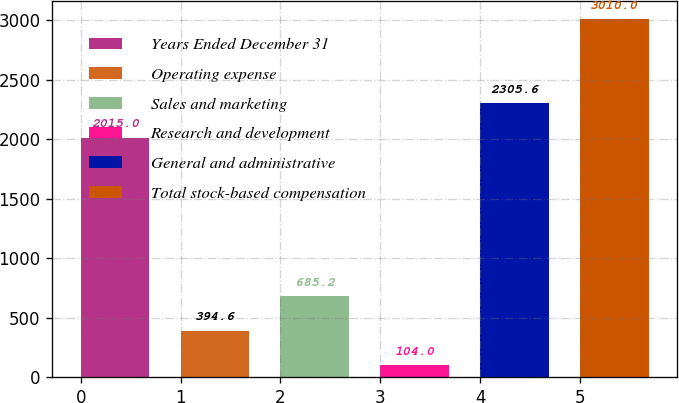Convert chart to OTSL. <chart><loc_0><loc_0><loc_500><loc_500><bar_chart><fcel>Years Ended December 31<fcel>Operating expense<fcel>Sales and marketing<fcel>Research and development<fcel>General and administrative<fcel>Total stock-based compensation<nl><fcel>2015<fcel>394.6<fcel>685.2<fcel>104<fcel>2305.6<fcel>3010<nl></chart> 